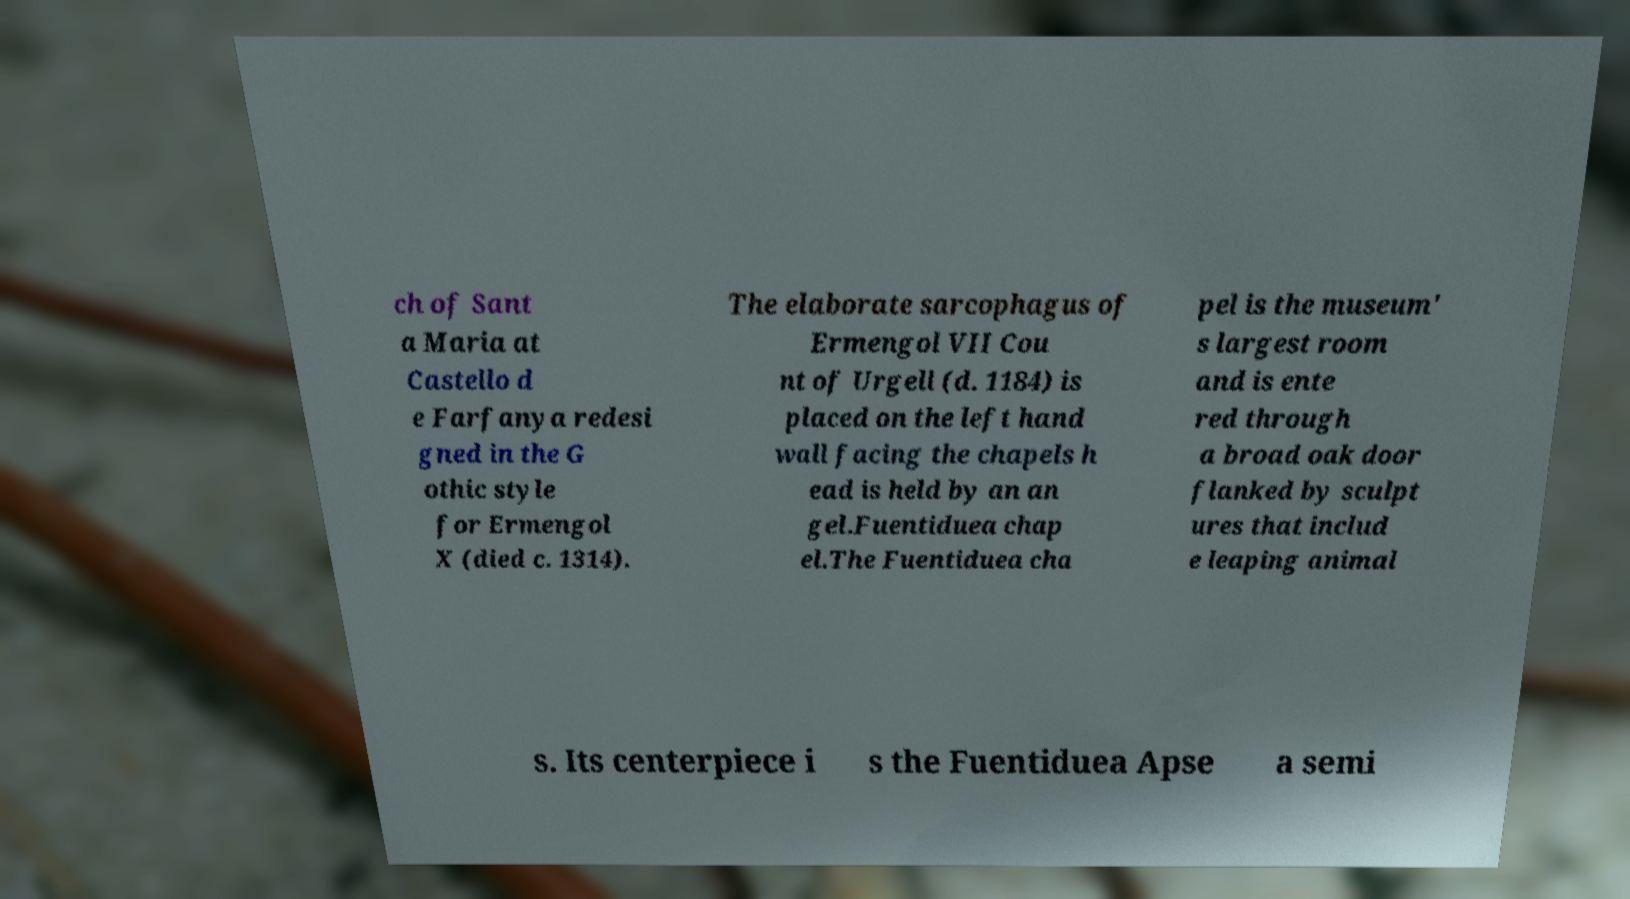There's text embedded in this image that I need extracted. Can you transcribe it verbatim? ch of Sant a Maria at Castello d e Farfanya redesi gned in the G othic style for Ermengol X (died c. 1314). The elaborate sarcophagus of Ermengol VII Cou nt of Urgell (d. 1184) is placed on the left hand wall facing the chapels h ead is held by an an gel.Fuentiduea chap el.The Fuentiduea cha pel is the museum' s largest room and is ente red through a broad oak door flanked by sculpt ures that includ e leaping animal s. Its centerpiece i s the Fuentiduea Apse a semi 